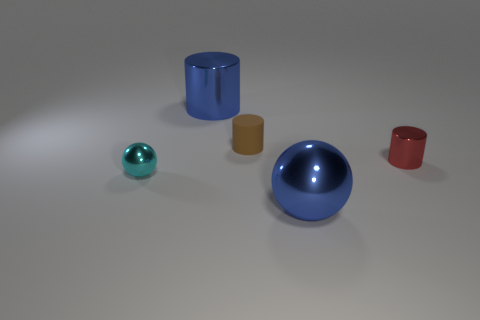Are there any other things that have the same material as the brown cylinder?
Keep it short and to the point. No. How many shiny objects are either big things or tiny cyan balls?
Keep it short and to the point. 3. Is the number of tiny rubber objects that are in front of the large sphere less than the number of big red spheres?
Offer a very short reply. No. What is the shape of the large blue object that is behind the small metal object that is on the right side of the big blue metallic object to the left of the large ball?
Ensure brevity in your answer.  Cylinder. Do the small matte object and the small ball have the same color?
Provide a short and direct response. No. Are there more big cyan matte spheres than brown cylinders?
Keep it short and to the point. No. How many other things are the same material as the brown cylinder?
Give a very brief answer. 0. How many objects are either red objects or metal things to the right of the small brown matte thing?
Offer a very short reply. 2. Is the number of tiny balls less than the number of blue shiny objects?
Make the answer very short. Yes. There is a metallic cylinder to the right of the blue shiny thing right of the big blue object to the left of the big blue sphere; what is its color?
Ensure brevity in your answer.  Red. 